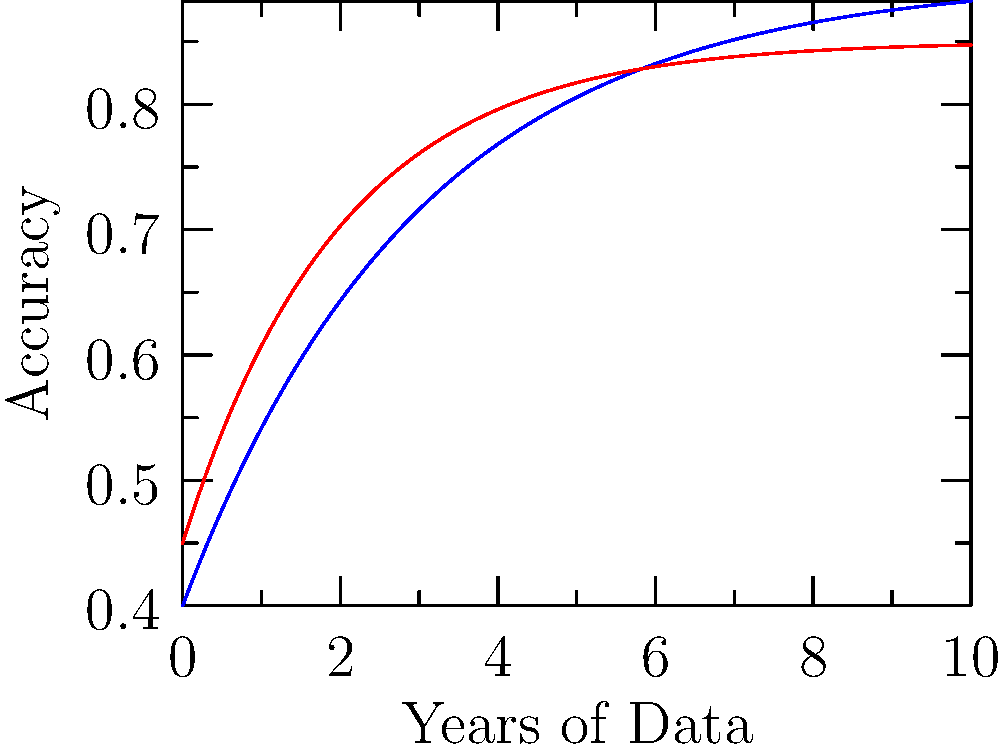Based on the graph showing AI predictions versus actual patient outcomes over time, what can be inferred about the accuracy of AI in predicting patient outcomes as more historical health data becomes available? To answer this question, let's analyze the graph step-by-step:

1. The blue line represents AI predictions, while the red line represents actual outcomes.

2. Both lines show an upward trend over time, indicating improved accuracy as more years of data become available.

3. The AI prediction line (blue) starts higher and increases more rapidly than the actual outcomes line (red).

4. As time progresses, the gap between the two lines narrows, suggesting that AI predictions become more aligned with actual outcomes.

5. However, the AI prediction line consistently remains above the actual outcomes line, indicating a tendency for AI to slightly overestimate accuracy.

6. By the end of the 10-year period shown, both lines appear to be approaching an asymptote, suggesting diminishing returns in accuracy improvements with additional data.

7. The final accuracy for AI predictions appears to be around 90%, while actual outcomes reach approximately 85%.

Given these observations, we can infer that AI accuracy in predicting patient outcomes improves with more historical health data, but it tends to slightly overestimate its performance. The improvement in accuracy shows diminishing returns over time, suggesting there may be limitations to how much additional data can enhance predictions.
Answer: AI accuracy improves with more data but slightly overestimates performance, showing diminishing returns over time. 